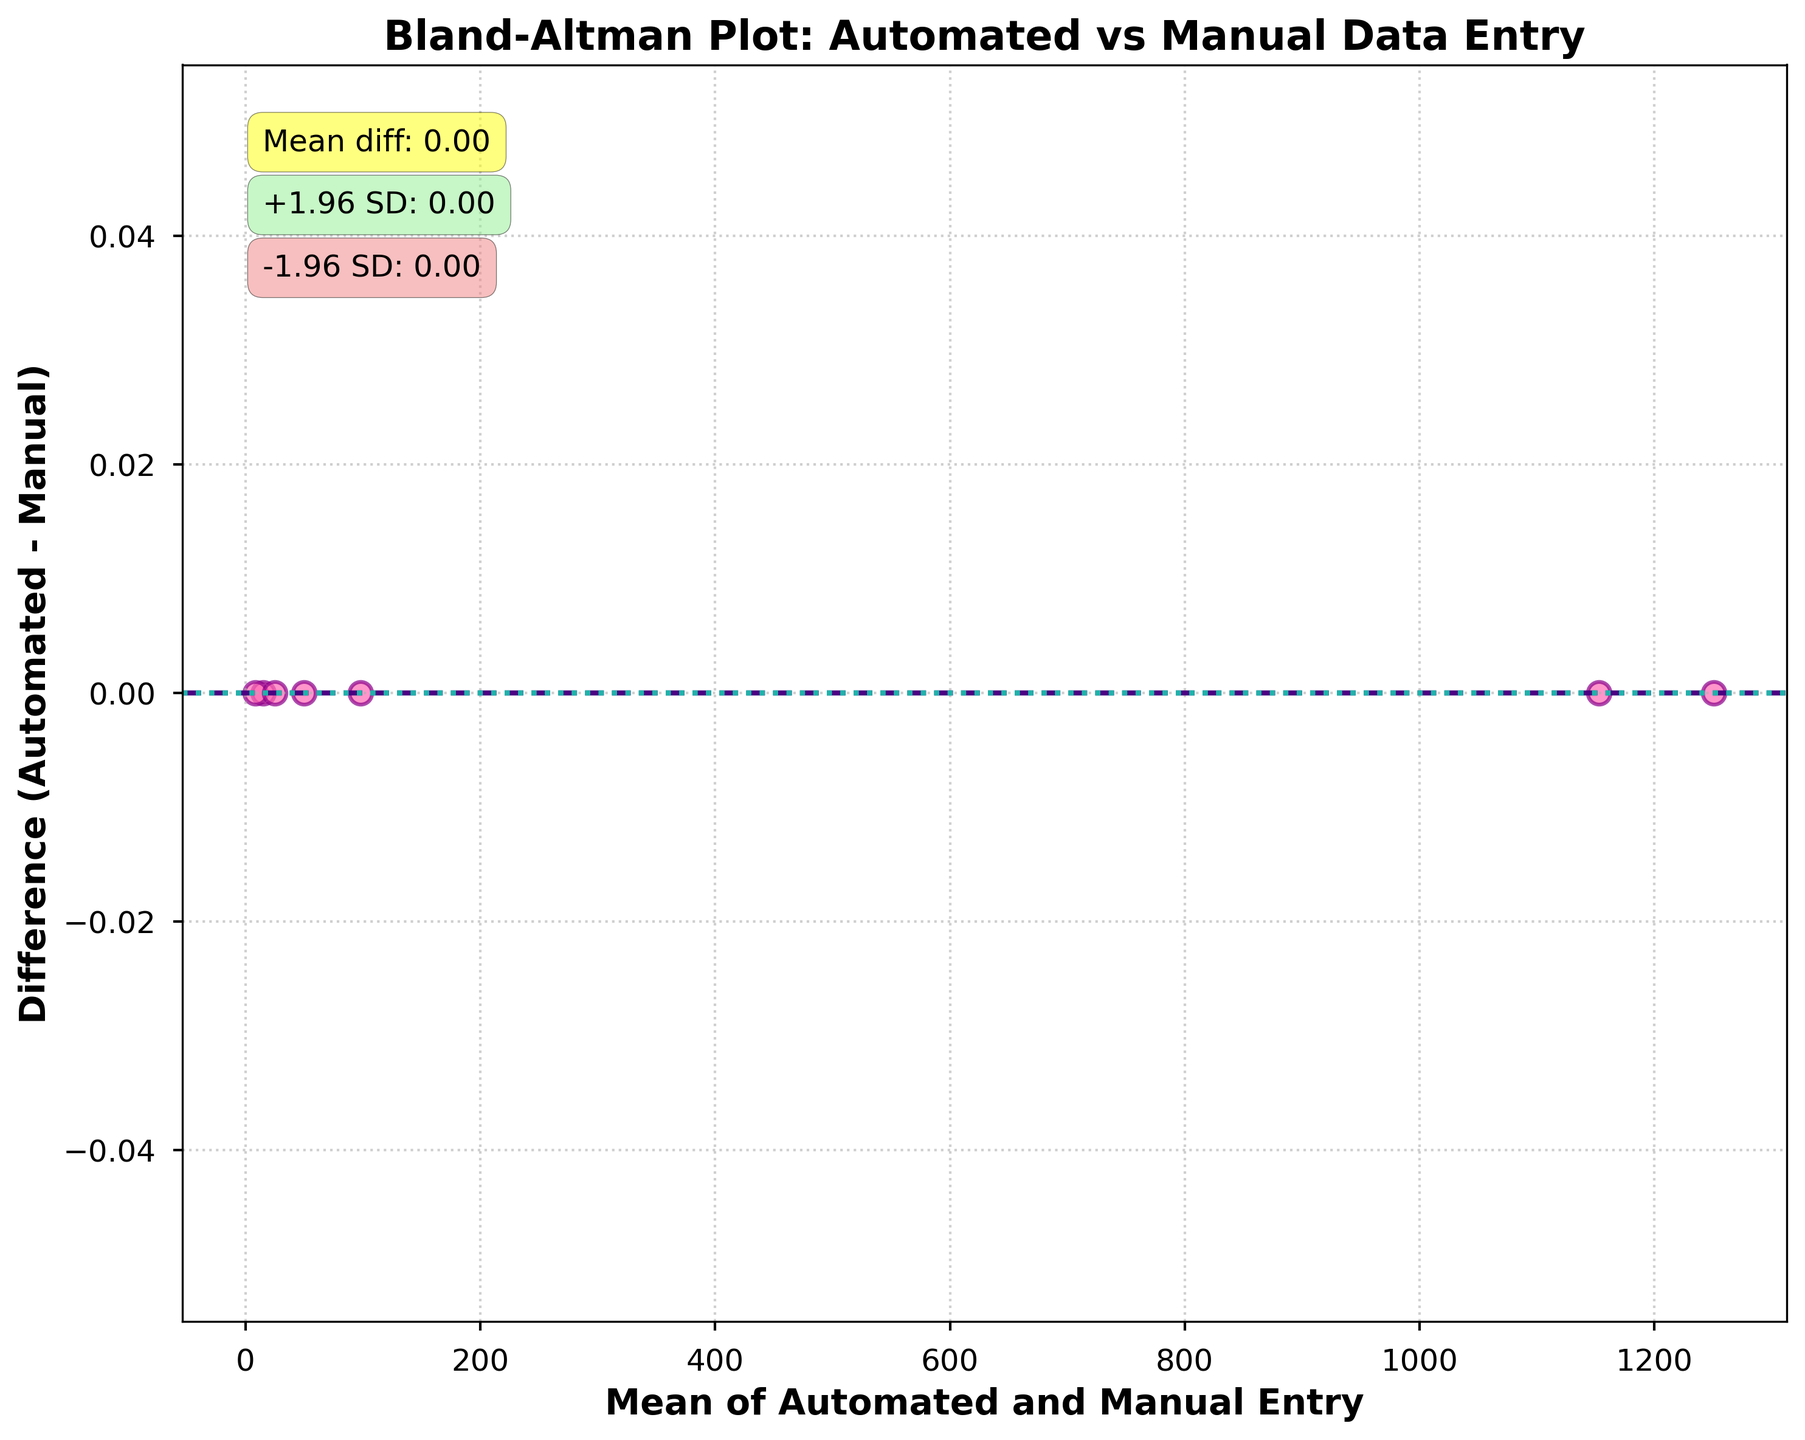What is the title of the plot? The title is usually located at the top of the plot and often describes the main purpose or content of the graph. In this case, it is "Bland-Altman Plot: Automated vs Manual Data Entry".
Answer: Bland-Altman Plot: Automated vs Manual Data Entry What does the x-axis represent? The label on the x-axis shows that it represents "Mean of Automated and Manual Entry", indicating it represents the average of the data points from automated and manual entries.
Answer: Mean of Automated and Manual Entry What does the y-axis represent? The label on the y-axis shows it represents the "Difference (Automated - Manual)", indicating it plots the difference between the automated and manual data entries.
Answer: Difference (Automated - Manual) What is the mean difference between automated and manual data entry? The mean difference is annotated on the plot, usually as a horizontal line with the value displayed around it. The annotation shows it as 0.00.
Answer: 0.00 What do the dashed and dotted lines on the plot signify? The dashed line represents the mean difference (0.00). The dotted lines represent the limits of agreement, calculated as the mean difference ± 1.96 times the standard deviation of the differences. They show the spread and agreement between the two methods.
Answer: Mean difference and limits of agreement What are the values of the limits of agreement on the plot? The limits of agreement are annotated on the plot. The annotations show +1.96 SD as 0.00 and -1.96 SD as 0.00. This indicates no dispersion between automated and manual entries.
Answer: 0.00 and 0.00 How many data points are plotted in the figure? The data points are shown as individual scatter points on the plot. Counting each point, you can see there are five scatter points.
Answer: 5 Are there any significant differences shown between the automated and manual entry methods? Significant differences would appear as large deviations from the mean difference line outside the limits of agreement. Since all data points align perfectly on the mean difference line with annotations of 0.00, no significant differences are present.
Answer: No significant differences What does it indicate if many points lie outside the limits of agreement in a Bland-Altman plot? Points outside the limits of agreement indicate discrepancies between the two methods being compared, suggesting they may not be in agreement and that one method may be systematically higher or lower than the other.
Answer: Discrepancies between methods 